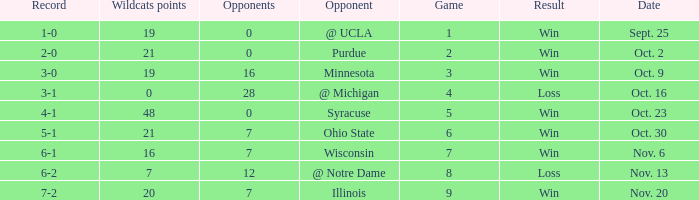How many wins or losses were there when the record was 3-0? 1.0. 